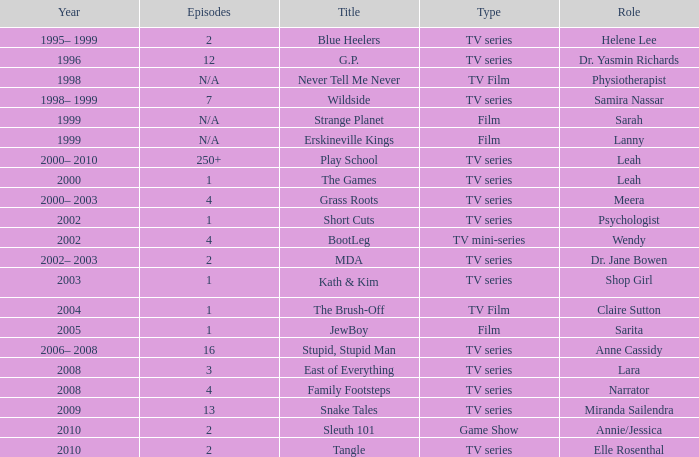What episode is called jewboy 1.0. 